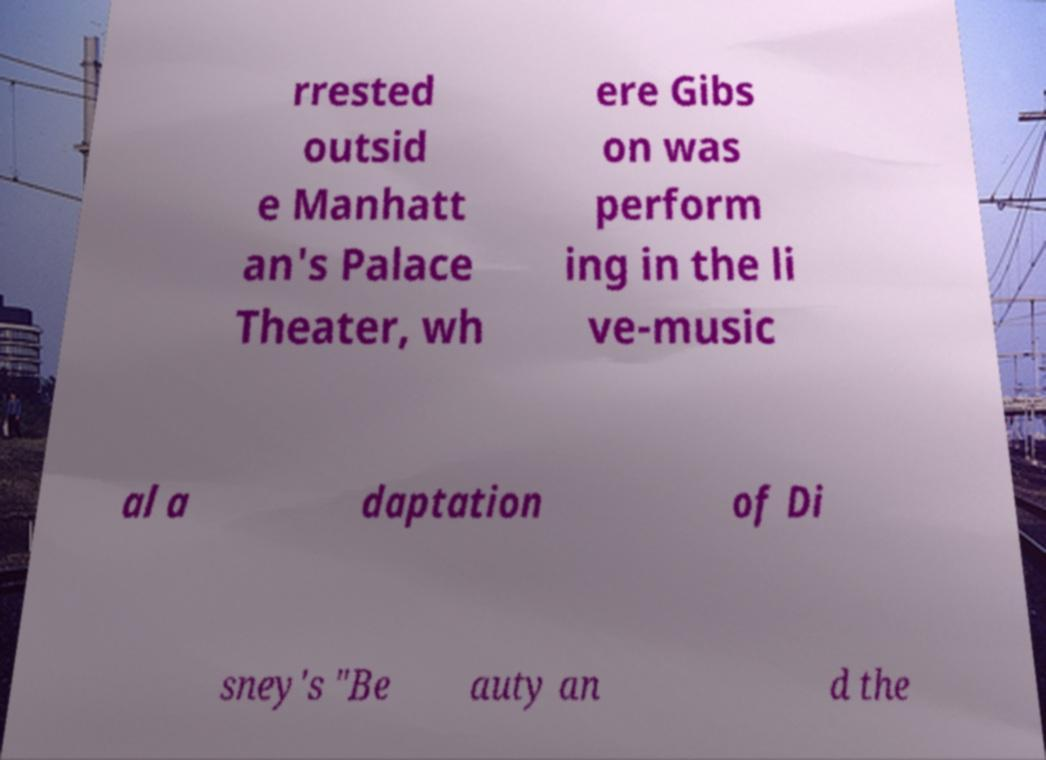What messages or text are displayed in this image? I need them in a readable, typed format. rrested outsid e Manhatt an's Palace Theater, wh ere Gibs on was perform ing in the li ve-music al a daptation of Di sney's "Be auty an d the 